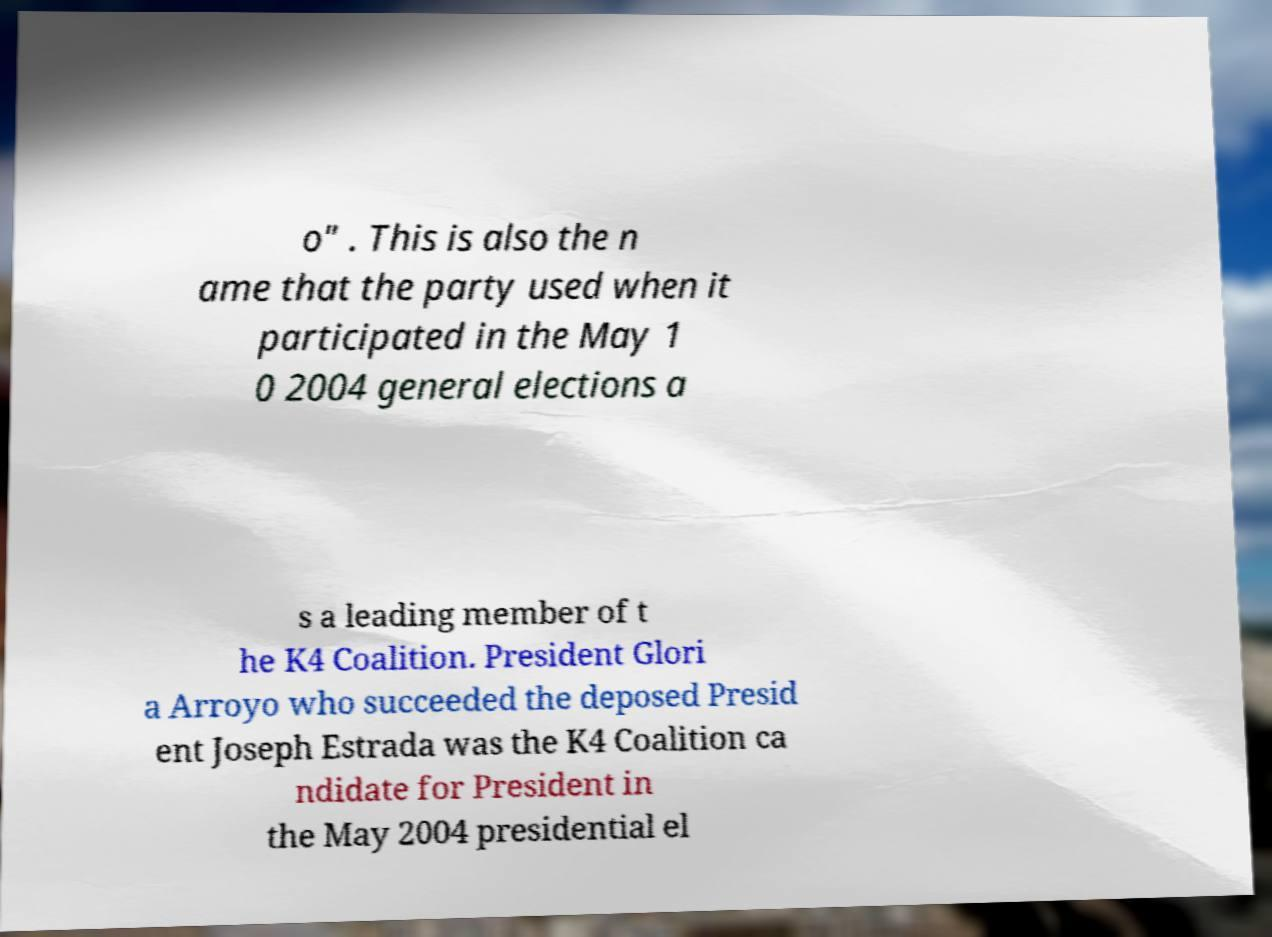Could you assist in decoding the text presented in this image and type it out clearly? o" . This is also the n ame that the party used when it participated in the May 1 0 2004 general elections a s a leading member of t he K4 Coalition. President Glori a Arroyo who succeeded the deposed Presid ent Joseph Estrada was the K4 Coalition ca ndidate for President in the May 2004 presidential el 